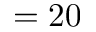<formula> <loc_0><loc_0><loc_500><loc_500>= 2 0</formula> 